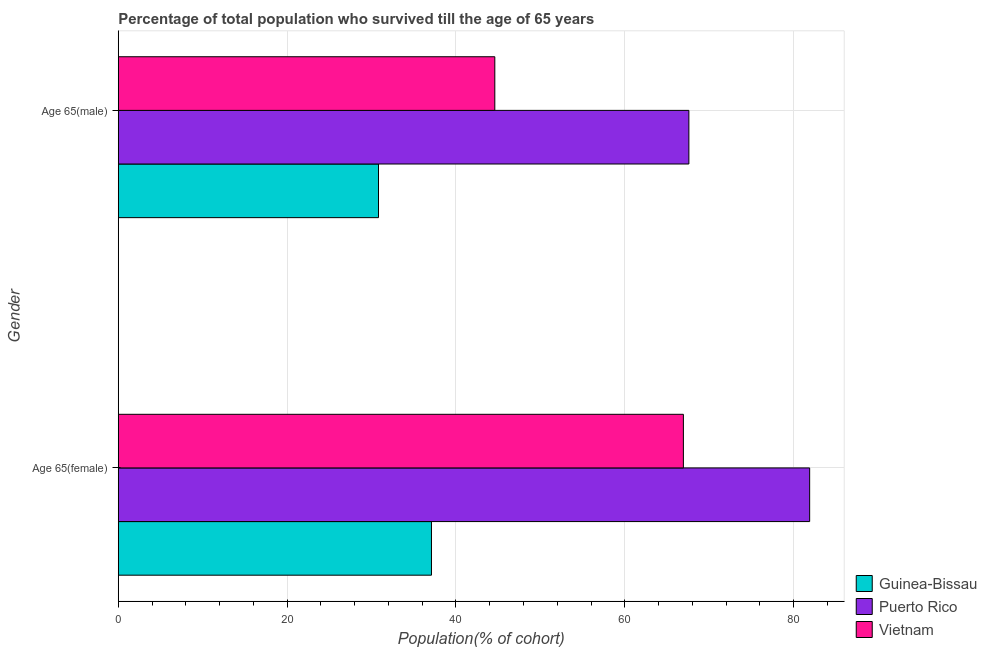Are the number of bars per tick equal to the number of legend labels?
Your response must be concise. Yes. Are the number of bars on each tick of the Y-axis equal?
Your answer should be compact. Yes. What is the label of the 2nd group of bars from the top?
Ensure brevity in your answer.  Age 65(female). What is the percentage of male population who survived till age of 65 in Vietnam?
Give a very brief answer. 44.6. Across all countries, what is the maximum percentage of female population who survived till age of 65?
Provide a succinct answer. 81.9. Across all countries, what is the minimum percentage of female population who survived till age of 65?
Provide a short and direct response. 37.1. In which country was the percentage of male population who survived till age of 65 maximum?
Provide a succinct answer. Puerto Rico. In which country was the percentage of male population who survived till age of 65 minimum?
Provide a short and direct response. Guinea-Bissau. What is the total percentage of male population who survived till age of 65 in the graph?
Keep it short and to the point. 143.01. What is the difference between the percentage of female population who survived till age of 65 in Puerto Rico and that in Vietnam?
Offer a very short reply. 14.96. What is the difference between the percentage of male population who survived till age of 65 in Puerto Rico and the percentage of female population who survived till age of 65 in Vietnam?
Provide a succinct answer. 0.65. What is the average percentage of female population who survived till age of 65 per country?
Your answer should be very brief. 61.98. What is the difference between the percentage of male population who survived till age of 65 and percentage of female population who survived till age of 65 in Guinea-Bissau?
Give a very brief answer. -6.27. In how many countries, is the percentage of male population who survived till age of 65 greater than 68 %?
Your answer should be compact. 0. What is the ratio of the percentage of male population who survived till age of 65 in Guinea-Bissau to that in Puerto Rico?
Offer a terse response. 0.46. Is the percentage of male population who survived till age of 65 in Vietnam less than that in Guinea-Bissau?
Keep it short and to the point. No. In how many countries, is the percentage of female population who survived till age of 65 greater than the average percentage of female population who survived till age of 65 taken over all countries?
Your response must be concise. 2. What does the 1st bar from the top in Age 65(male) represents?
Your response must be concise. Vietnam. What does the 1st bar from the bottom in Age 65(male) represents?
Ensure brevity in your answer.  Guinea-Bissau. How many bars are there?
Offer a terse response. 6. How many countries are there in the graph?
Make the answer very short. 3. Where does the legend appear in the graph?
Your answer should be compact. Bottom right. How many legend labels are there?
Your answer should be very brief. 3. What is the title of the graph?
Provide a short and direct response. Percentage of total population who survived till the age of 65 years. What is the label or title of the X-axis?
Provide a short and direct response. Population(% of cohort). What is the label or title of the Y-axis?
Offer a terse response. Gender. What is the Population(% of cohort) of Guinea-Bissau in Age 65(female)?
Give a very brief answer. 37.1. What is the Population(% of cohort) of Puerto Rico in Age 65(female)?
Offer a very short reply. 81.9. What is the Population(% of cohort) of Vietnam in Age 65(female)?
Your answer should be very brief. 66.94. What is the Population(% of cohort) in Guinea-Bissau in Age 65(male)?
Ensure brevity in your answer.  30.82. What is the Population(% of cohort) of Puerto Rico in Age 65(male)?
Keep it short and to the point. 67.59. What is the Population(% of cohort) in Vietnam in Age 65(male)?
Offer a very short reply. 44.6. Across all Gender, what is the maximum Population(% of cohort) of Guinea-Bissau?
Your response must be concise. 37.1. Across all Gender, what is the maximum Population(% of cohort) in Puerto Rico?
Give a very brief answer. 81.9. Across all Gender, what is the maximum Population(% of cohort) in Vietnam?
Keep it short and to the point. 66.94. Across all Gender, what is the minimum Population(% of cohort) in Guinea-Bissau?
Your response must be concise. 30.82. Across all Gender, what is the minimum Population(% of cohort) in Puerto Rico?
Your answer should be compact. 67.59. Across all Gender, what is the minimum Population(% of cohort) in Vietnam?
Keep it short and to the point. 44.6. What is the total Population(% of cohort) in Guinea-Bissau in the graph?
Make the answer very short. 67.92. What is the total Population(% of cohort) of Puerto Rico in the graph?
Offer a terse response. 149.48. What is the total Population(% of cohort) of Vietnam in the graph?
Your response must be concise. 111.54. What is the difference between the Population(% of cohort) of Guinea-Bissau in Age 65(female) and that in Age 65(male)?
Make the answer very short. 6.27. What is the difference between the Population(% of cohort) of Puerto Rico in Age 65(female) and that in Age 65(male)?
Provide a short and direct response. 14.31. What is the difference between the Population(% of cohort) of Vietnam in Age 65(female) and that in Age 65(male)?
Keep it short and to the point. 22.34. What is the difference between the Population(% of cohort) in Guinea-Bissau in Age 65(female) and the Population(% of cohort) in Puerto Rico in Age 65(male)?
Make the answer very short. -30.49. What is the difference between the Population(% of cohort) of Guinea-Bissau in Age 65(female) and the Population(% of cohort) of Vietnam in Age 65(male)?
Offer a terse response. -7.5. What is the difference between the Population(% of cohort) in Puerto Rico in Age 65(female) and the Population(% of cohort) in Vietnam in Age 65(male)?
Provide a succinct answer. 37.3. What is the average Population(% of cohort) of Guinea-Bissau per Gender?
Ensure brevity in your answer.  33.96. What is the average Population(% of cohort) of Puerto Rico per Gender?
Offer a terse response. 74.74. What is the average Population(% of cohort) in Vietnam per Gender?
Your answer should be compact. 55.77. What is the difference between the Population(% of cohort) in Guinea-Bissau and Population(% of cohort) in Puerto Rico in Age 65(female)?
Make the answer very short. -44.8. What is the difference between the Population(% of cohort) of Guinea-Bissau and Population(% of cohort) of Vietnam in Age 65(female)?
Provide a short and direct response. -29.84. What is the difference between the Population(% of cohort) in Puerto Rico and Population(% of cohort) in Vietnam in Age 65(female)?
Provide a short and direct response. 14.96. What is the difference between the Population(% of cohort) of Guinea-Bissau and Population(% of cohort) of Puerto Rico in Age 65(male)?
Make the answer very short. -36.77. What is the difference between the Population(% of cohort) in Guinea-Bissau and Population(% of cohort) in Vietnam in Age 65(male)?
Your answer should be compact. -13.78. What is the difference between the Population(% of cohort) in Puerto Rico and Population(% of cohort) in Vietnam in Age 65(male)?
Your answer should be very brief. 22.99. What is the ratio of the Population(% of cohort) in Guinea-Bissau in Age 65(female) to that in Age 65(male)?
Your answer should be very brief. 1.2. What is the ratio of the Population(% of cohort) in Puerto Rico in Age 65(female) to that in Age 65(male)?
Provide a succinct answer. 1.21. What is the ratio of the Population(% of cohort) in Vietnam in Age 65(female) to that in Age 65(male)?
Your answer should be very brief. 1.5. What is the difference between the highest and the second highest Population(% of cohort) of Guinea-Bissau?
Keep it short and to the point. 6.27. What is the difference between the highest and the second highest Population(% of cohort) of Puerto Rico?
Make the answer very short. 14.31. What is the difference between the highest and the second highest Population(% of cohort) of Vietnam?
Your answer should be compact. 22.34. What is the difference between the highest and the lowest Population(% of cohort) in Guinea-Bissau?
Give a very brief answer. 6.27. What is the difference between the highest and the lowest Population(% of cohort) in Puerto Rico?
Ensure brevity in your answer.  14.31. What is the difference between the highest and the lowest Population(% of cohort) of Vietnam?
Provide a short and direct response. 22.34. 